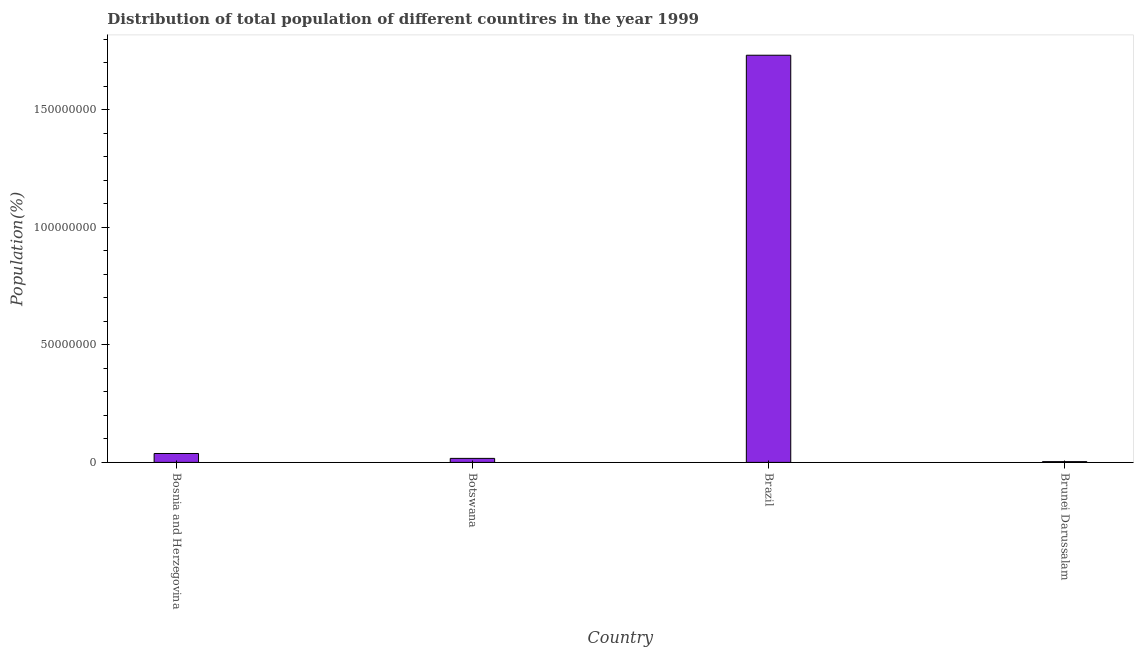Does the graph contain any zero values?
Make the answer very short. No. Does the graph contain grids?
Make the answer very short. No. What is the title of the graph?
Offer a terse response. Distribution of total population of different countires in the year 1999. What is the label or title of the X-axis?
Make the answer very short. Country. What is the label or title of the Y-axis?
Your response must be concise. Population(%). What is the population in Botswana?
Provide a short and direct response. 1.71e+06. Across all countries, what is the maximum population?
Offer a terse response. 1.73e+08. Across all countries, what is the minimum population?
Keep it short and to the point. 3.24e+05. In which country was the population minimum?
Your answer should be compact. Brunei Darussalam. What is the sum of the population?
Your response must be concise. 1.79e+08. What is the difference between the population in Brazil and Brunei Darussalam?
Give a very brief answer. 1.73e+08. What is the average population per country?
Your answer should be very brief. 4.47e+07. What is the median population?
Your response must be concise. 2.75e+06. In how many countries, is the population greater than 140000000 %?
Provide a short and direct response. 1. What is the ratio of the population in Bosnia and Herzegovina to that in Botswana?
Provide a short and direct response. 2.21. Is the population in Bosnia and Herzegovina less than that in Brunei Darussalam?
Keep it short and to the point. No. What is the difference between the highest and the second highest population?
Provide a short and direct response. 1.69e+08. What is the difference between the highest and the lowest population?
Ensure brevity in your answer.  1.73e+08. How many bars are there?
Offer a very short reply. 4. How many countries are there in the graph?
Your answer should be very brief. 4. What is the difference between two consecutive major ticks on the Y-axis?
Offer a very short reply. 5.00e+07. What is the Population(%) of Bosnia and Herzegovina?
Provide a short and direct response. 3.78e+06. What is the Population(%) of Botswana?
Ensure brevity in your answer.  1.71e+06. What is the Population(%) in Brazil?
Keep it short and to the point. 1.73e+08. What is the Population(%) in Brunei Darussalam?
Your answer should be very brief. 3.24e+05. What is the difference between the Population(%) in Bosnia and Herzegovina and Botswana?
Provide a succinct answer. 2.08e+06. What is the difference between the Population(%) in Bosnia and Herzegovina and Brazil?
Your answer should be very brief. -1.69e+08. What is the difference between the Population(%) in Bosnia and Herzegovina and Brunei Darussalam?
Your response must be concise. 3.46e+06. What is the difference between the Population(%) in Botswana and Brazil?
Give a very brief answer. -1.71e+08. What is the difference between the Population(%) in Botswana and Brunei Darussalam?
Keep it short and to the point. 1.38e+06. What is the difference between the Population(%) in Brazil and Brunei Darussalam?
Offer a very short reply. 1.73e+08. What is the ratio of the Population(%) in Bosnia and Herzegovina to that in Botswana?
Provide a short and direct response. 2.21. What is the ratio of the Population(%) in Bosnia and Herzegovina to that in Brazil?
Your response must be concise. 0.02. What is the ratio of the Population(%) in Bosnia and Herzegovina to that in Brunei Darussalam?
Give a very brief answer. 11.69. What is the ratio of the Population(%) in Botswana to that in Brunei Darussalam?
Offer a terse response. 5.28. What is the ratio of the Population(%) in Brazil to that in Brunei Darussalam?
Provide a short and direct response. 534.73. 